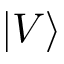Convert formula to latex. <formula><loc_0><loc_0><loc_500><loc_500>| V \rangle</formula> 